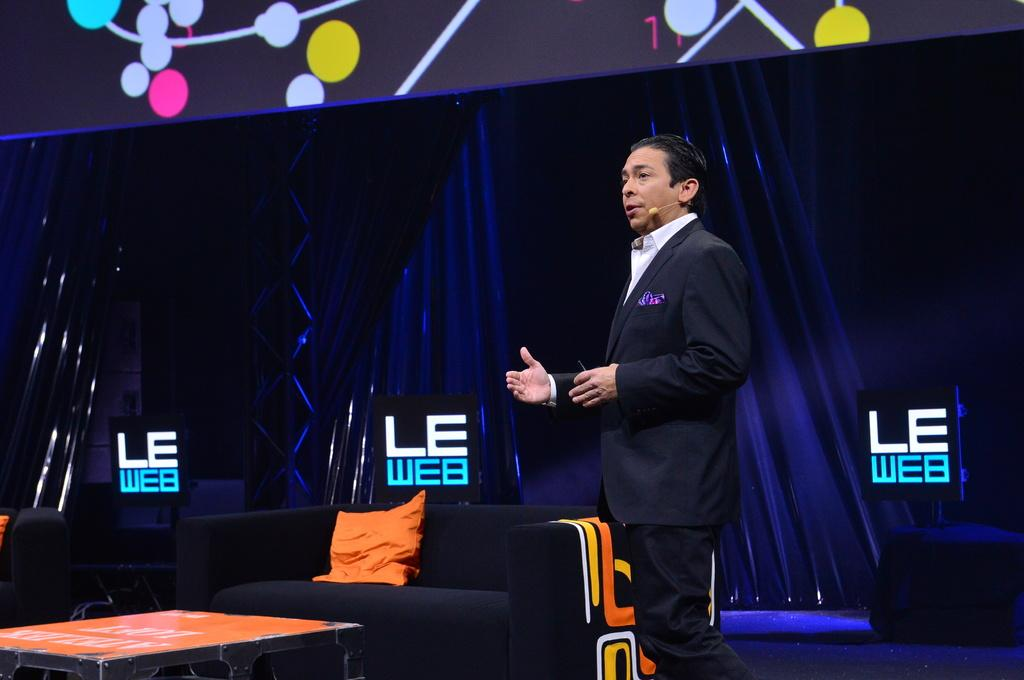<image>
Render a clear and concise summary of the photo. A logo for LE Web can be seen behind a man speaking. 